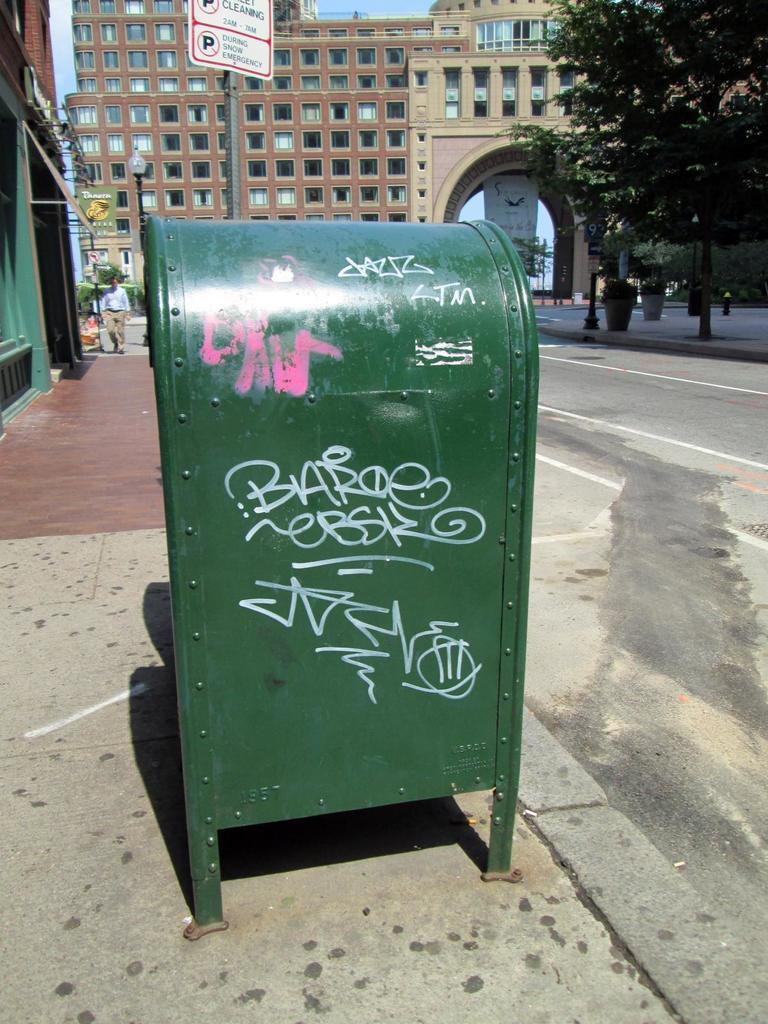Provide a one-sentence caption for the provided image. Green mailbox with graffitti on it under a sign which says no parking. 